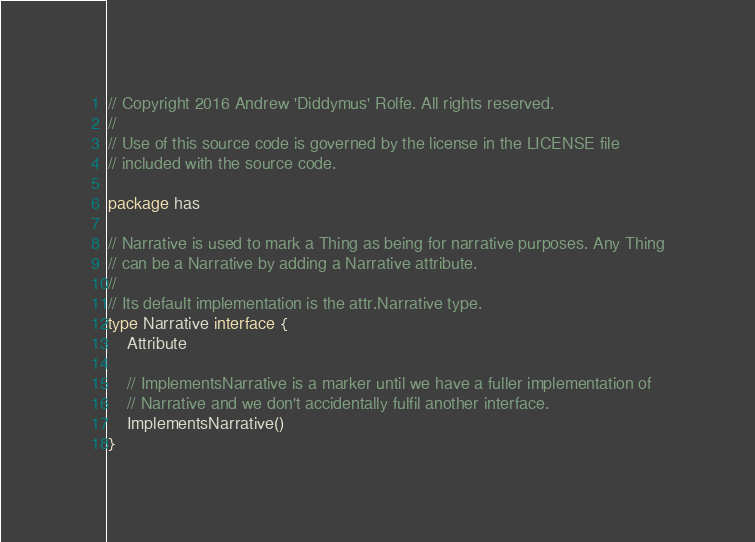Convert code to text. <code><loc_0><loc_0><loc_500><loc_500><_Go_>// Copyright 2016 Andrew 'Diddymus' Rolfe. All rights reserved.
//
// Use of this source code is governed by the license in the LICENSE file
// included with the source code.

package has

// Narrative is used to mark a Thing as being for narrative purposes. Any Thing
// can be a Narrative by adding a Narrative attribute.
//
// Its default implementation is the attr.Narrative type.
type Narrative interface {
	Attribute

	// ImplementsNarrative is a marker until we have a fuller implementation of
	// Narrative and we don't accidentally fulfil another interface.
	ImplementsNarrative()
}
</code> 